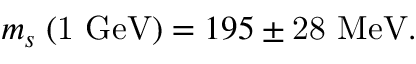Convert formula to latex. <formula><loc_0><loc_0><loc_500><loc_500>m _ { s } \, ( 1 G e V ) = 1 9 5 \pm 2 8 M e V .</formula> 